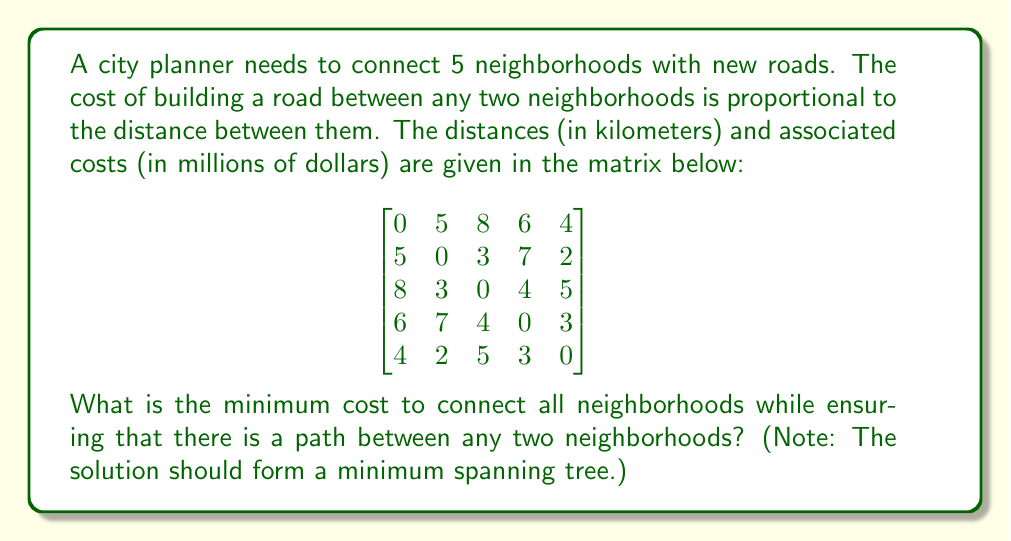Can you answer this question? To solve this problem, we need to find the minimum spanning tree (MST) of the graph represented by the given distance matrix. The MST will connect all neighborhoods with the minimum total cost while ensuring connectivity between all pairs of neighborhoods.

We can use Kruskal's algorithm to find the MST:

1. Sort all edges by weight (cost) in ascending order:
   (2,5): 2, (2,3): 3, (4,5): 3, (1,5): 4, (3,4): 4, (1,2): 5, (2,4): 7, (1,3): 8, (1,4): 6

2. Start with an empty set of edges and add edges in order, skipping those that would create a cycle:

   a. Add (2,5): 2
   b. Add (2,3): 3
   c. Add (4,5): 3
   d. Add (1,5): 4

3. Stop when we have added n-1 edges, where n is the number of neighborhoods (5 in this case).

The resulting MST consists of the following edges:
(2,5), (2,3), (4,5), (1,5)

To calculate the total cost, sum the costs of these edges:
$2 + 3 + 3 + 4 = 12$

Therefore, the minimum cost to connect all neighborhoods while ensuring connectivity is $12 million.

[asy]
unitsize(30);
pair[] nodes = {(0,0), (2,2), (4,0), (4,2), (2,0)};
string[] labels = {"1", "2", "3", "4", "5"};

for (int i = 0; i < 5; ++i) {
  dot(nodes[i]);
  label(labels[i], nodes[i], NE);
}

draw(nodes[1]--nodes[4], blue+1);
draw(nodes[1]--nodes[2], blue+1);
draw(nodes[3]--nodes[4], blue+1);
draw(nodes[0]--nodes[4], blue+1);

label("2", (nodes[1]+nodes[4])/2, N);
label("3", (nodes[1]+nodes[2])/2, SE);
label("3", (nodes[3]+nodes[4])/2, N);
label("4", (nodes[0]+nodes[4])/2, SE);
[/asy]
Answer: The minimum cost to connect all neighborhoods while ensuring connectivity is $12 million. 